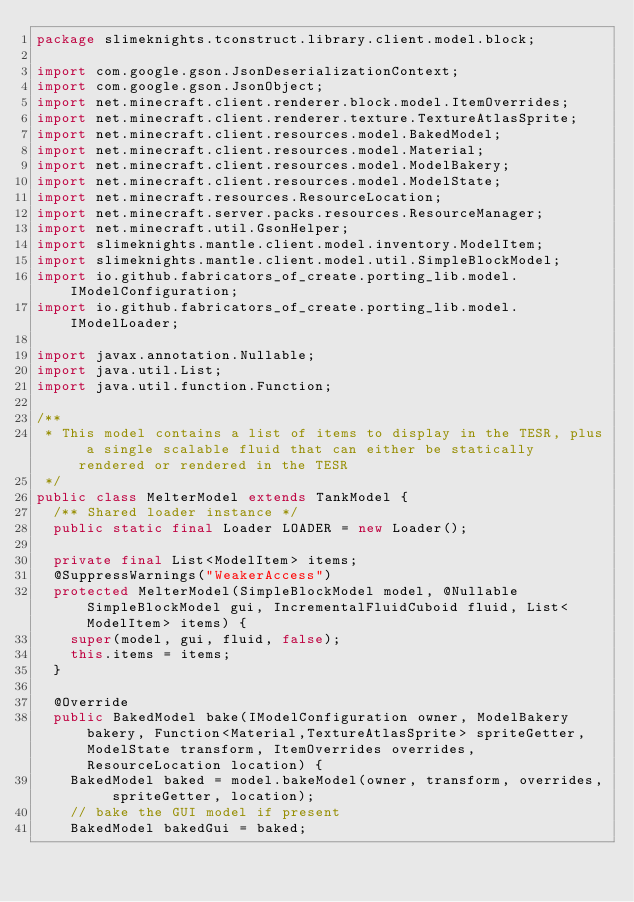Convert code to text. <code><loc_0><loc_0><loc_500><loc_500><_Java_>package slimeknights.tconstruct.library.client.model.block;

import com.google.gson.JsonDeserializationContext;
import com.google.gson.JsonObject;
import net.minecraft.client.renderer.block.model.ItemOverrides;
import net.minecraft.client.renderer.texture.TextureAtlasSprite;
import net.minecraft.client.resources.model.BakedModel;
import net.minecraft.client.resources.model.Material;
import net.minecraft.client.resources.model.ModelBakery;
import net.minecraft.client.resources.model.ModelState;
import net.minecraft.resources.ResourceLocation;
import net.minecraft.server.packs.resources.ResourceManager;
import net.minecraft.util.GsonHelper;
import slimeknights.mantle.client.model.inventory.ModelItem;
import slimeknights.mantle.client.model.util.SimpleBlockModel;
import io.github.fabricators_of_create.porting_lib.model.IModelConfiguration;
import io.github.fabricators_of_create.porting_lib.model.IModelLoader;

import javax.annotation.Nullable;
import java.util.List;
import java.util.function.Function;

/**
 * This model contains a list of items to display in the TESR, plus a single scalable fluid that can either be statically rendered or rendered in the TESR
 */
public class MelterModel extends TankModel {
  /** Shared loader instance */
  public static final Loader LOADER = new Loader();

  private final List<ModelItem> items;
  @SuppressWarnings("WeakerAccess")
  protected MelterModel(SimpleBlockModel model, @Nullable SimpleBlockModel gui, IncrementalFluidCuboid fluid, List<ModelItem> items) {
    super(model, gui, fluid, false);
    this.items = items;
  }

  @Override
  public BakedModel bake(IModelConfiguration owner, ModelBakery bakery, Function<Material,TextureAtlasSprite> spriteGetter, ModelState transform, ItemOverrides overrides, ResourceLocation location) {
    BakedModel baked = model.bakeModel(owner, transform, overrides, spriteGetter, location);
    // bake the GUI model if present
    BakedModel bakedGui = baked;</code> 